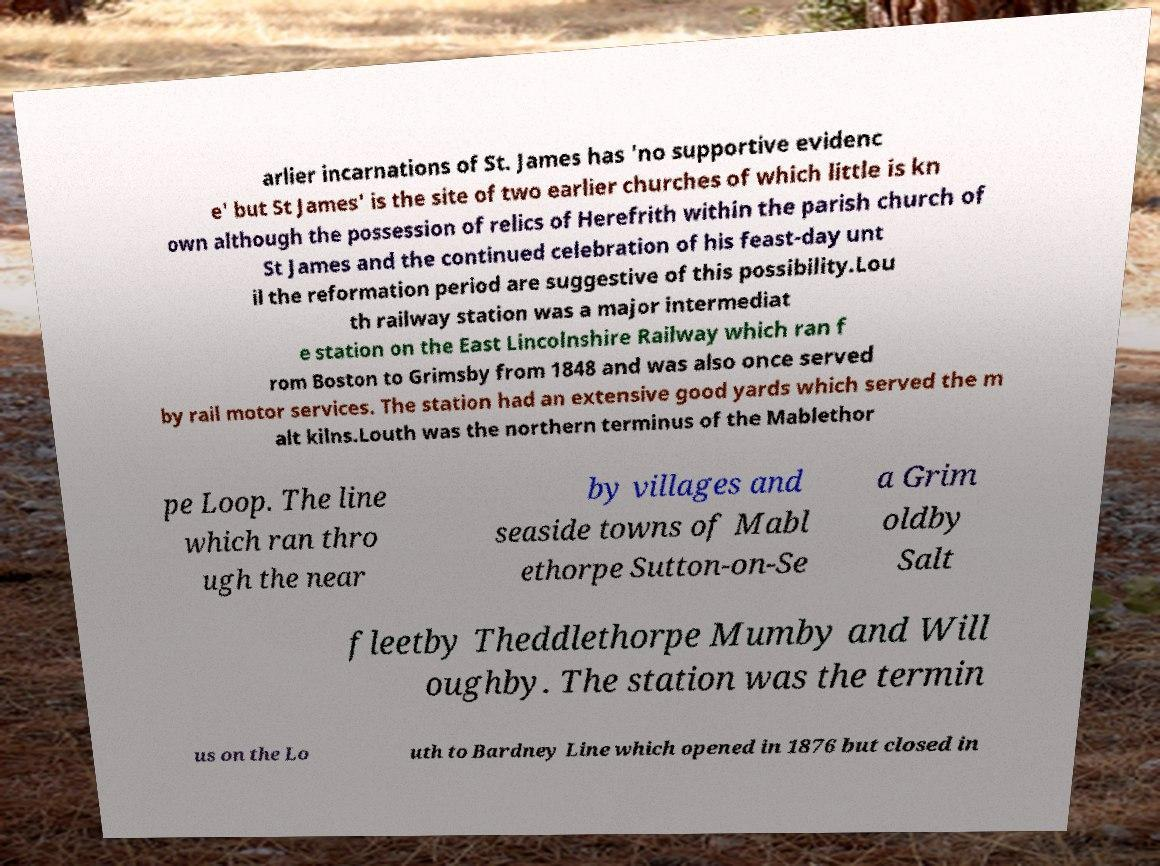Please read and relay the text visible in this image. What does it say? arlier incarnations of St. James has 'no supportive evidenc e' but St James' is the site of two earlier churches of which little is kn own although the possession of relics of Herefrith within the parish church of St James and the continued celebration of his feast-day unt il the reformation period are suggestive of this possibility.Lou th railway station was a major intermediat e station on the East Lincolnshire Railway which ran f rom Boston to Grimsby from 1848 and was also once served by rail motor services. The station had an extensive good yards which served the m alt kilns.Louth was the northern terminus of the Mablethor pe Loop. The line which ran thro ugh the near by villages and seaside towns of Mabl ethorpe Sutton-on-Se a Grim oldby Salt fleetby Theddlethorpe Mumby and Will oughby. The station was the termin us on the Lo uth to Bardney Line which opened in 1876 but closed in 